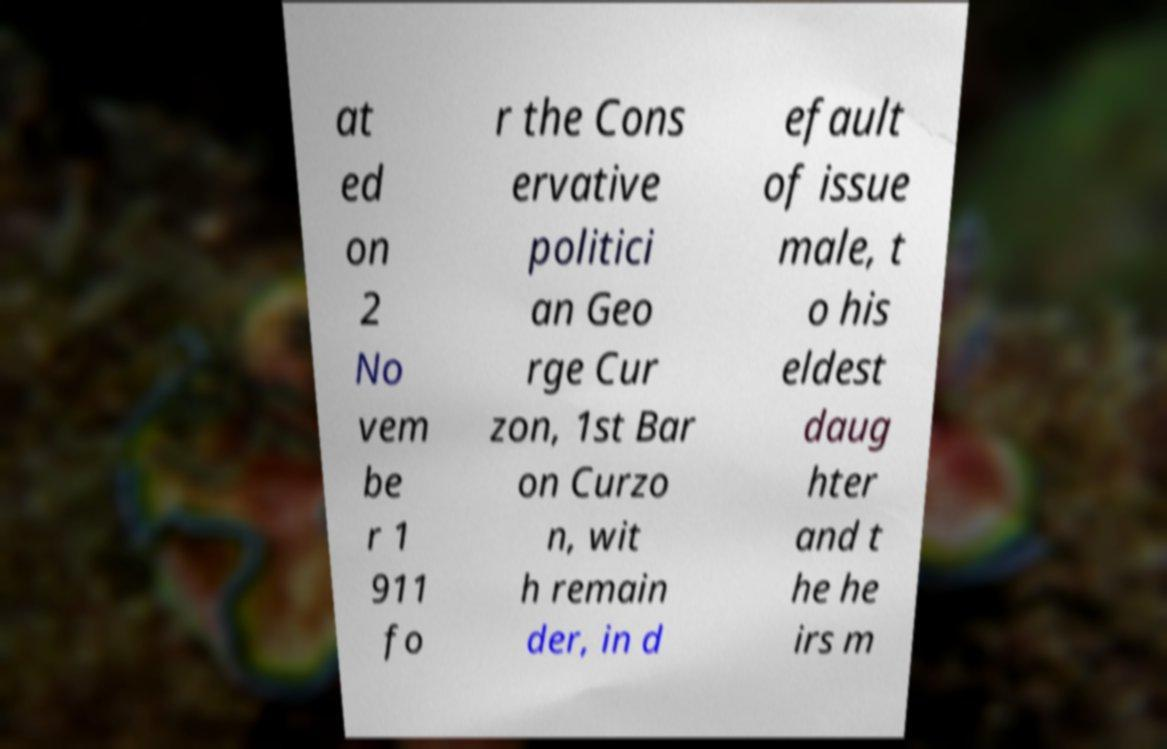For documentation purposes, I need the text within this image transcribed. Could you provide that? at ed on 2 No vem be r 1 911 fo r the Cons ervative politici an Geo rge Cur zon, 1st Bar on Curzo n, wit h remain der, in d efault of issue male, t o his eldest daug hter and t he he irs m 